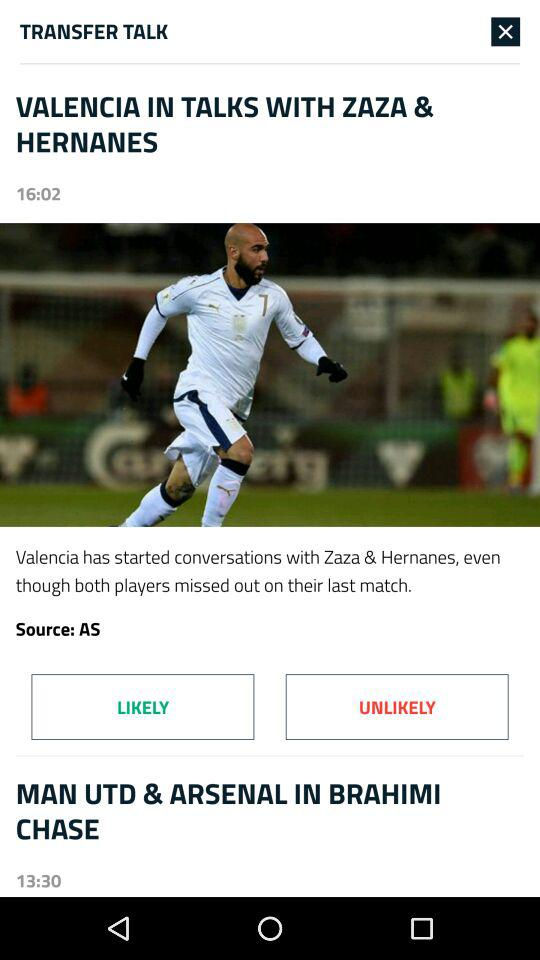What is the publication time of "VALENCIA IN TALKS WITH ZAZA & HERNANES"? The publication time is 16:02. 